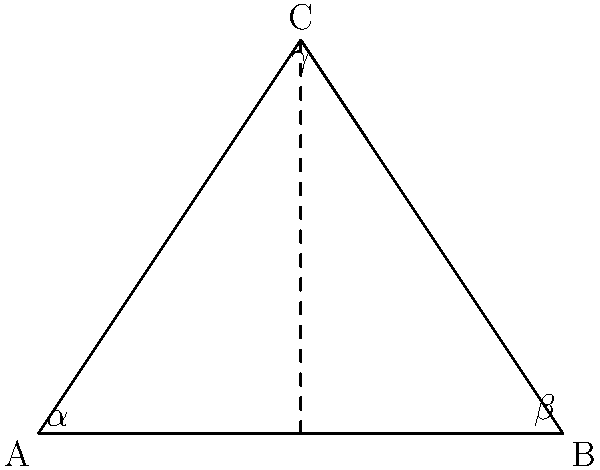In a hyperbolic triangle ABC, the angles are $\alpha$, $\beta$, and $\gamma$. Unlike in Euclidean geometry, the sum of these angles is less than 180°. If the difference between 180° and the sum of the angles is called the defect ($\delta$), and the area of the triangle is 0.5 square units, what is the sum of the angles in radians? (Hint: Use the Gauss-Bonnet theorem, which states that in hyperbolic geometry, the area of a triangle is proportional to its defect) Let's approach this step-by-step:

1) The Gauss-Bonnet theorem for hyperbolic triangles states that:
   $$A = k\delta$$
   where $A$ is the area, $k$ is a constant (in this case, $k = 1$), and $\delta$ is the defect.

2) We're given that the area $A = 0.5$ square units, so:
   $$0.5 = \delta$$

3) The defect $\delta$ is defined as:
   $$\delta = \pi - (\alpha + \beta + \gamma)$$
   where $\pi$ is in radians (equivalent to 180°).

4) Substituting our known value for $\delta$:
   $$0.5 = \pi - (\alpha + \beta + \gamma)$$

5) Solving for the sum of the angles:
   $$(\alpha + \beta + \gamma) = \pi - 0.5$$

6) $\pi$ is approximately 3.14159 radians, so:
   $$(\alpha + \beta + \gamma) = 3.14159 - 0.5 = 2.64159$$

Therefore, the sum of the angles in the hyperbolic triangle is approximately 2.64159 radians.
Answer: 2.64159 radians 